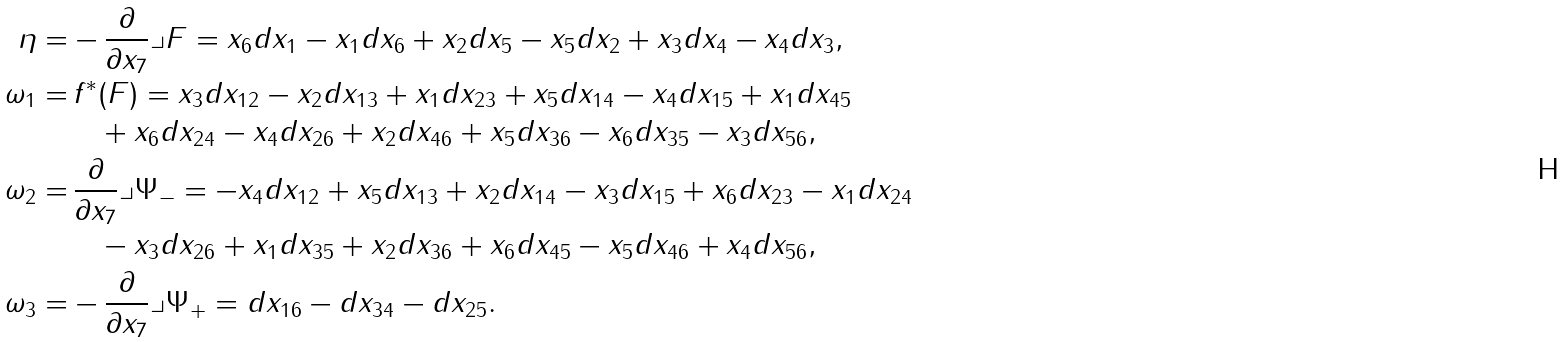<formula> <loc_0><loc_0><loc_500><loc_500>\eta = & - \frac { \partial } { \partial x _ { 7 } } \lrcorner F = x _ { 6 } d x _ { 1 } - x _ { 1 } d x _ { 6 } + x _ { 2 } d x _ { 5 } - x _ { 5 } d x _ { 2 } + x _ { 3 } d x _ { 4 } - x _ { 4 } d x _ { 3 } , \\ \omega _ { 1 } = & \, f ^ { * } ( F ) = x _ { 3 } d x _ { 1 2 } - x _ { 2 } d x _ { 1 3 } + x _ { 1 } d x _ { 2 3 } + x _ { 5 } d x _ { 1 4 } - x _ { 4 } d x _ { 1 5 } + x _ { 1 } d x _ { 4 5 } \\ & \quad + x _ { 6 } d x _ { 2 4 } - x _ { 4 } d x _ { 2 6 } + x _ { 2 } d x _ { 4 6 } + x _ { 5 } d x _ { 3 6 } - x _ { 6 } d x _ { 3 5 } - x _ { 3 } d x _ { 5 6 } , \\ \omega _ { 2 } = & \, \frac { \partial } { \partial x _ { 7 } } \lrcorner \Psi _ { - } = - x _ { 4 } d x _ { 1 2 } + x _ { 5 } d x _ { 1 3 } + x _ { 2 } d x _ { 1 4 } - x _ { 3 } d x _ { 1 5 } + x _ { 6 } d x _ { 2 3 } - x _ { 1 } d x _ { 2 4 } \\ & \quad - x _ { 3 } d x _ { 2 6 } + x _ { 1 } d x _ { 3 5 } + x _ { 2 } d x _ { 3 6 } + x _ { 6 } d x _ { 4 5 } - x _ { 5 } d x _ { 4 6 } + x _ { 4 } d x _ { 5 6 } , \\ \omega _ { 3 } = & - \frac { \partial } { \partial x _ { 7 } } \lrcorner \Psi _ { + } = d x _ { 1 6 } - d x _ { 3 4 } - d x _ { 2 5 } .</formula> 